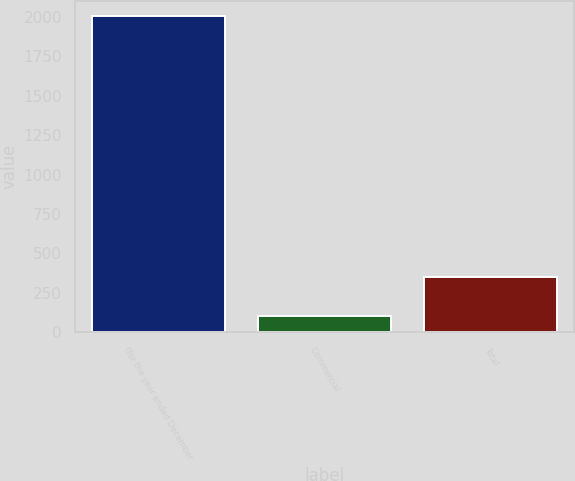<chart> <loc_0><loc_0><loc_500><loc_500><bar_chart><fcel>(for the year ended December<fcel>Commercial<fcel>Total<nl><fcel>2003<fcel>103<fcel>352<nl></chart> 